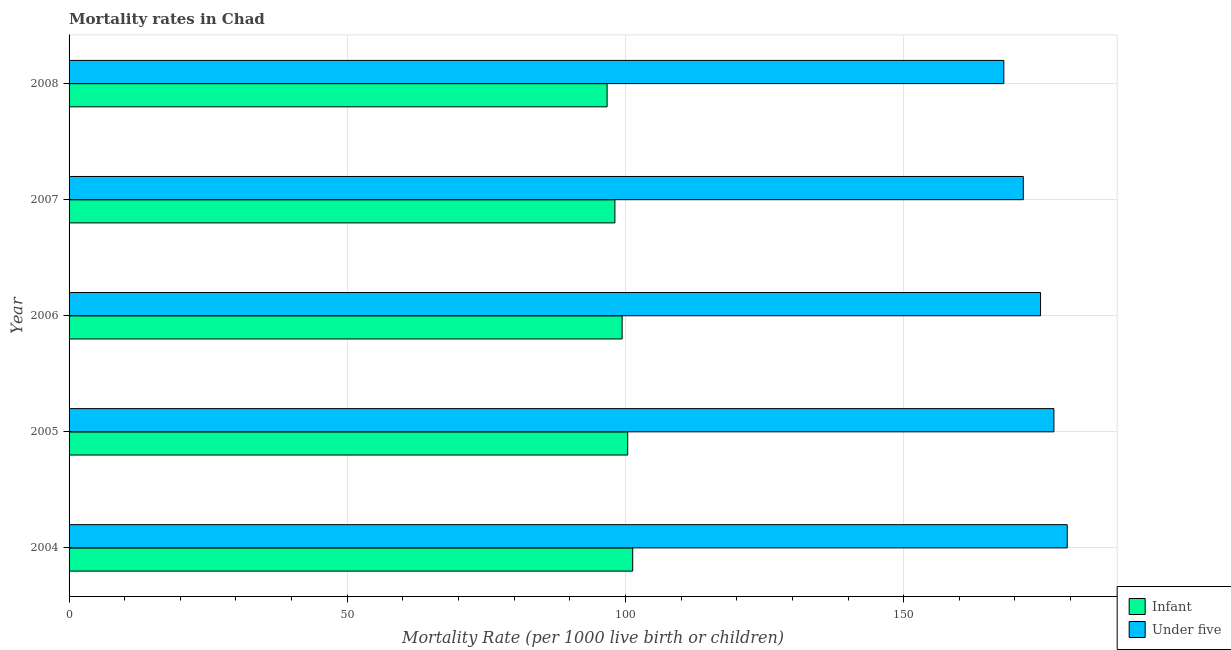How many different coloured bars are there?
Provide a short and direct response. 2. How many groups of bars are there?
Ensure brevity in your answer.  5. Are the number of bars on each tick of the Y-axis equal?
Your response must be concise. Yes. How many bars are there on the 3rd tick from the top?
Offer a terse response. 2. How many bars are there on the 3rd tick from the bottom?
Keep it short and to the point. 2. What is the label of the 1st group of bars from the top?
Ensure brevity in your answer.  2008. What is the under-5 mortality rate in 2008?
Provide a short and direct response. 168. Across all years, what is the maximum infant mortality rate?
Your answer should be compact. 101.3. Across all years, what is the minimum under-5 mortality rate?
Ensure brevity in your answer.  168. In which year was the under-5 mortality rate maximum?
Offer a very short reply. 2004. In which year was the infant mortality rate minimum?
Your answer should be very brief. 2008. What is the total under-5 mortality rate in the graph?
Ensure brevity in your answer.  870.5. What is the difference between the infant mortality rate in 2007 and that in 2008?
Offer a terse response. 1.4. What is the difference between the under-5 mortality rate in 2006 and the infant mortality rate in 2008?
Your answer should be compact. 77.9. What is the average infant mortality rate per year?
Offer a terse response. 99.18. In the year 2005, what is the difference between the infant mortality rate and under-5 mortality rate?
Offer a very short reply. -76.6. What is the ratio of the infant mortality rate in 2004 to that in 2008?
Offer a very short reply. 1.05. Is the under-5 mortality rate in 2004 less than that in 2007?
Ensure brevity in your answer.  No. What is the difference between the highest and the second highest under-5 mortality rate?
Make the answer very short. 2.4. What is the difference between the highest and the lowest infant mortality rate?
Offer a terse response. 4.6. Is the sum of the under-5 mortality rate in 2006 and 2008 greater than the maximum infant mortality rate across all years?
Offer a terse response. Yes. What does the 2nd bar from the top in 2007 represents?
Make the answer very short. Infant. What does the 2nd bar from the bottom in 2005 represents?
Provide a succinct answer. Under five. What is the difference between two consecutive major ticks on the X-axis?
Your answer should be compact. 50. Does the graph contain any zero values?
Offer a terse response. No. Does the graph contain grids?
Your response must be concise. Yes. Where does the legend appear in the graph?
Make the answer very short. Bottom right. How many legend labels are there?
Your answer should be compact. 2. What is the title of the graph?
Make the answer very short. Mortality rates in Chad. What is the label or title of the X-axis?
Provide a succinct answer. Mortality Rate (per 1000 live birth or children). What is the label or title of the Y-axis?
Offer a very short reply. Year. What is the Mortality Rate (per 1000 live birth or children) in Infant in 2004?
Provide a short and direct response. 101.3. What is the Mortality Rate (per 1000 live birth or children) of Under five in 2004?
Give a very brief answer. 179.4. What is the Mortality Rate (per 1000 live birth or children) of Infant in 2005?
Keep it short and to the point. 100.4. What is the Mortality Rate (per 1000 live birth or children) in Under five in 2005?
Your response must be concise. 177. What is the Mortality Rate (per 1000 live birth or children) in Infant in 2006?
Your answer should be compact. 99.4. What is the Mortality Rate (per 1000 live birth or children) of Under five in 2006?
Your answer should be very brief. 174.6. What is the Mortality Rate (per 1000 live birth or children) in Infant in 2007?
Your answer should be very brief. 98.1. What is the Mortality Rate (per 1000 live birth or children) in Under five in 2007?
Provide a succinct answer. 171.5. What is the Mortality Rate (per 1000 live birth or children) of Infant in 2008?
Make the answer very short. 96.7. What is the Mortality Rate (per 1000 live birth or children) of Under five in 2008?
Make the answer very short. 168. Across all years, what is the maximum Mortality Rate (per 1000 live birth or children) in Infant?
Provide a short and direct response. 101.3. Across all years, what is the maximum Mortality Rate (per 1000 live birth or children) of Under five?
Provide a succinct answer. 179.4. Across all years, what is the minimum Mortality Rate (per 1000 live birth or children) in Infant?
Provide a short and direct response. 96.7. Across all years, what is the minimum Mortality Rate (per 1000 live birth or children) of Under five?
Keep it short and to the point. 168. What is the total Mortality Rate (per 1000 live birth or children) of Infant in the graph?
Make the answer very short. 495.9. What is the total Mortality Rate (per 1000 live birth or children) of Under five in the graph?
Make the answer very short. 870.5. What is the difference between the Mortality Rate (per 1000 live birth or children) of Infant in 2004 and that in 2006?
Provide a short and direct response. 1.9. What is the difference between the Mortality Rate (per 1000 live birth or children) of Under five in 2004 and that in 2007?
Your response must be concise. 7.9. What is the difference between the Mortality Rate (per 1000 live birth or children) of Under five in 2004 and that in 2008?
Keep it short and to the point. 11.4. What is the difference between the Mortality Rate (per 1000 live birth or children) of Under five in 2005 and that in 2006?
Offer a terse response. 2.4. What is the difference between the Mortality Rate (per 1000 live birth or children) in Infant in 2005 and that in 2008?
Offer a terse response. 3.7. What is the difference between the Mortality Rate (per 1000 live birth or children) in Under five in 2005 and that in 2008?
Provide a short and direct response. 9. What is the difference between the Mortality Rate (per 1000 live birth or children) of Under five in 2006 and that in 2007?
Your answer should be very brief. 3.1. What is the difference between the Mortality Rate (per 1000 live birth or children) in Under five in 2007 and that in 2008?
Offer a very short reply. 3.5. What is the difference between the Mortality Rate (per 1000 live birth or children) in Infant in 2004 and the Mortality Rate (per 1000 live birth or children) in Under five in 2005?
Provide a succinct answer. -75.7. What is the difference between the Mortality Rate (per 1000 live birth or children) in Infant in 2004 and the Mortality Rate (per 1000 live birth or children) in Under five in 2006?
Provide a succinct answer. -73.3. What is the difference between the Mortality Rate (per 1000 live birth or children) in Infant in 2004 and the Mortality Rate (per 1000 live birth or children) in Under five in 2007?
Give a very brief answer. -70.2. What is the difference between the Mortality Rate (per 1000 live birth or children) in Infant in 2004 and the Mortality Rate (per 1000 live birth or children) in Under five in 2008?
Keep it short and to the point. -66.7. What is the difference between the Mortality Rate (per 1000 live birth or children) of Infant in 2005 and the Mortality Rate (per 1000 live birth or children) of Under five in 2006?
Offer a terse response. -74.2. What is the difference between the Mortality Rate (per 1000 live birth or children) in Infant in 2005 and the Mortality Rate (per 1000 live birth or children) in Under five in 2007?
Ensure brevity in your answer.  -71.1. What is the difference between the Mortality Rate (per 1000 live birth or children) in Infant in 2005 and the Mortality Rate (per 1000 live birth or children) in Under five in 2008?
Your answer should be very brief. -67.6. What is the difference between the Mortality Rate (per 1000 live birth or children) in Infant in 2006 and the Mortality Rate (per 1000 live birth or children) in Under five in 2007?
Provide a short and direct response. -72.1. What is the difference between the Mortality Rate (per 1000 live birth or children) of Infant in 2006 and the Mortality Rate (per 1000 live birth or children) of Under five in 2008?
Provide a succinct answer. -68.6. What is the difference between the Mortality Rate (per 1000 live birth or children) of Infant in 2007 and the Mortality Rate (per 1000 live birth or children) of Under five in 2008?
Keep it short and to the point. -69.9. What is the average Mortality Rate (per 1000 live birth or children) in Infant per year?
Ensure brevity in your answer.  99.18. What is the average Mortality Rate (per 1000 live birth or children) of Under five per year?
Offer a very short reply. 174.1. In the year 2004, what is the difference between the Mortality Rate (per 1000 live birth or children) in Infant and Mortality Rate (per 1000 live birth or children) in Under five?
Provide a short and direct response. -78.1. In the year 2005, what is the difference between the Mortality Rate (per 1000 live birth or children) in Infant and Mortality Rate (per 1000 live birth or children) in Under five?
Give a very brief answer. -76.6. In the year 2006, what is the difference between the Mortality Rate (per 1000 live birth or children) in Infant and Mortality Rate (per 1000 live birth or children) in Under five?
Your answer should be compact. -75.2. In the year 2007, what is the difference between the Mortality Rate (per 1000 live birth or children) in Infant and Mortality Rate (per 1000 live birth or children) in Under five?
Offer a terse response. -73.4. In the year 2008, what is the difference between the Mortality Rate (per 1000 live birth or children) of Infant and Mortality Rate (per 1000 live birth or children) of Under five?
Your response must be concise. -71.3. What is the ratio of the Mortality Rate (per 1000 live birth or children) in Infant in 2004 to that in 2005?
Offer a very short reply. 1.01. What is the ratio of the Mortality Rate (per 1000 live birth or children) of Under five in 2004 to that in 2005?
Offer a terse response. 1.01. What is the ratio of the Mortality Rate (per 1000 live birth or children) in Infant in 2004 to that in 2006?
Provide a succinct answer. 1.02. What is the ratio of the Mortality Rate (per 1000 live birth or children) of Under five in 2004 to that in 2006?
Keep it short and to the point. 1.03. What is the ratio of the Mortality Rate (per 1000 live birth or children) of Infant in 2004 to that in 2007?
Provide a short and direct response. 1.03. What is the ratio of the Mortality Rate (per 1000 live birth or children) of Under five in 2004 to that in 2007?
Keep it short and to the point. 1.05. What is the ratio of the Mortality Rate (per 1000 live birth or children) in Infant in 2004 to that in 2008?
Your answer should be very brief. 1.05. What is the ratio of the Mortality Rate (per 1000 live birth or children) of Under five in 2004 to that in 2008?
Offer a very short reply. 1.07. What is the ratio of the Mortality Rate (per 1000 live birth or children) of Infant in 2005 to that in 2006?
Your answer should be compact. 1.01. What is the ratio of the Mortality Rate (per 1000 live birth or children) of Under five in 2005 to that in 2006?
Your response must be concise. 1.01. What is the ratio of the Mortality Rate (per 1000 live birth or children) of Infant in 2005 to that in 2007?
Make the answer very short. 1.02. What is the ratio of the Mortality Rate (per 1000 live birth or children) of Under five in 2005 to that in 2007?
Offer a terse response. 1.03. What is the ratio of the Mortality Rate (per 1000 live birth or children) of Infant in 2005 to that in 2008?
Provide a succinct answer. 1.04. What is the ratio of the Mortality Rate (per 1000 live birth or children) in Under five in 2005 to that in 2008?
Offer a terse response. 1.05. What is the ratio of the Mortality Rate (per 1000 live birth or children) in Infant in 2006 to that in 2007?
Your answer should be very brief. 1.01. What is the ratio of the Mortality Rate (per 1000 live birth or children) in Under five in 2006 to that in 2007?
Provide a succinct answer. 1.02. What is the ratio of the Mortality Rate (per 1000 live birth or children) in Infant in 2006 to that in 2008?
Make the answer very short. 1.03. What is the ratio of the Mortality Rate (per 1000 live birth or children) in Under five in 2006 to that in 2008?
Provide a succinct answer. 1.04. What is the ratio of the Mortality Rate (per 1000 live birth or children) in Infant in 2007 to that in 2008?
Your answer should be compact. 1.01. What is the ratio of the Mortality Rate (per 1000 live birth or children) in Under five in 2007 to that in 2008?
Keep it short and to the point. 1.02. What is the difference between the highest and the second highest Mortality Rate (per 1000 live birth or children) in Infant?
Make the answer very short. 0.9. What is the difference between the highest and the second highest Mortality Rate (per 1000 live birth or children) in Under five?
Keep it short and to the point. 2.4. What is the difference between the highest and the lowest Mortality Rate (per 1000 live birth or children) of Under five?
Offer a terse response. 11.4. 